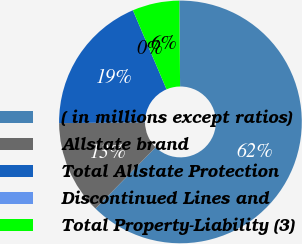<chart> <loc_0><loc_0><loc_500><loc_500><pie_chart><fcel>( in millions except ratios)<fcel>Allstate brand<fcel>Total Allstate Protection<fcel>Discontinued Lines and<fcel>Total Property-Liability (3)<nl><fcel>62.49%<fcel>12.5%<fcel>18.75%<fcel>0.0%<fcel>6.25%<nl></chart> 